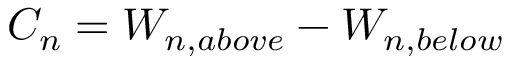<formula> <loc_0><loc_0><loc_500><loc_500>C _ { n } = W _ { n , a b o v e } - W _ { n , b e l o w }</formula> 